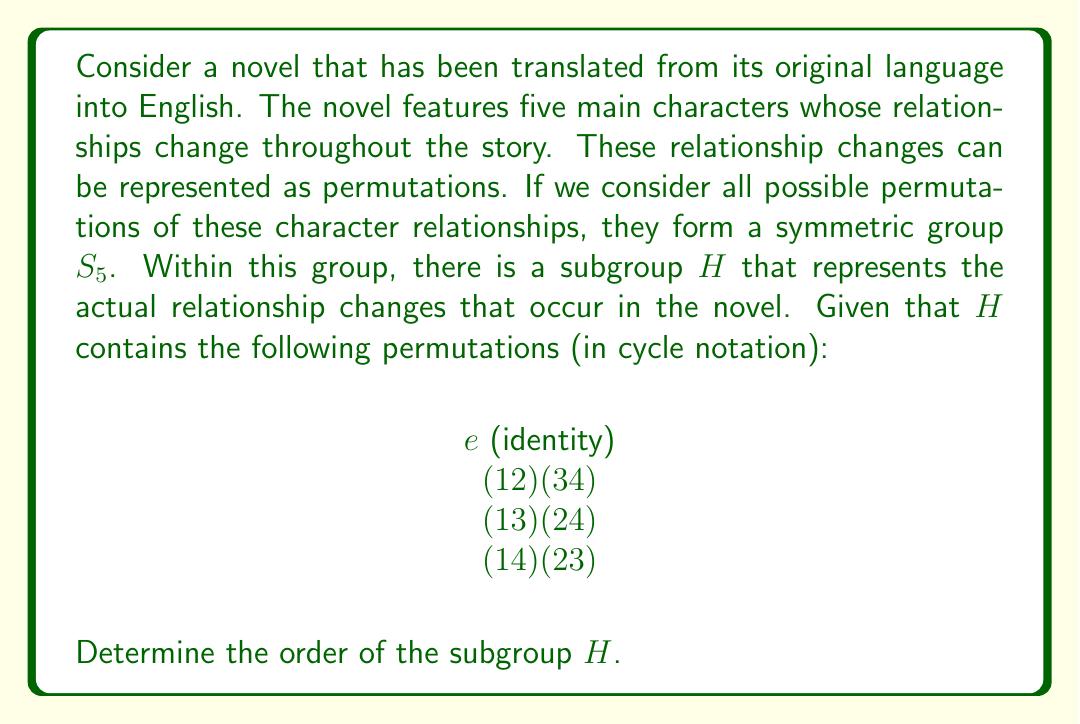Provide a solution to this math problem. To determine the order of the subgroup $H$, we need to follow these steps:

1) First, let's list all the elements of $H$:
   $e$, $(1 2)(3 4)$, $(1 3)(2 4)$, $(1 4)(2 3)$

2) We need to check if this is indeed a complete subgroup by verifying that it's closed under composition. Let's create a composition table:

   $$\begin{array}{c|cccc}
   \circ & e & (12)(34) & (13)(24) & (14)(23) \\
   \hline
   e & e & (12)(34) & (13)(24) & (14)(23) \\
   (12)(34) & (12)(34) & e & (14)(23) & (13)(24) \\
   (13)(24) & (13)(24) & (14)(23) & e & (12)(34) \\
   (14)(23) & (14)(23) & (13)(24) & (12)(34) & e
   \end{array}$$

3) We can see that the composition of any two elements in $H$ always results in an element that's also in $H$. This confirms that $H$ is indeed a subgroup.

4) The order of a group is the number of elements it contains. We can simply count the elements in $H$.

5) $H$ contains 4 elements: $e$, $(1 2)(3 4)$, $(1 3)(2 4)$, and $(1 4)(2 3)$.

Therefore, the order of subgroup $H$ is 4.

In the context of the novel, this means there are four distinct states of character relationships that the story cycles through, including the initial state (represented by the identity permutation).
Answer: The order of the subgroup $H$ is 4. 